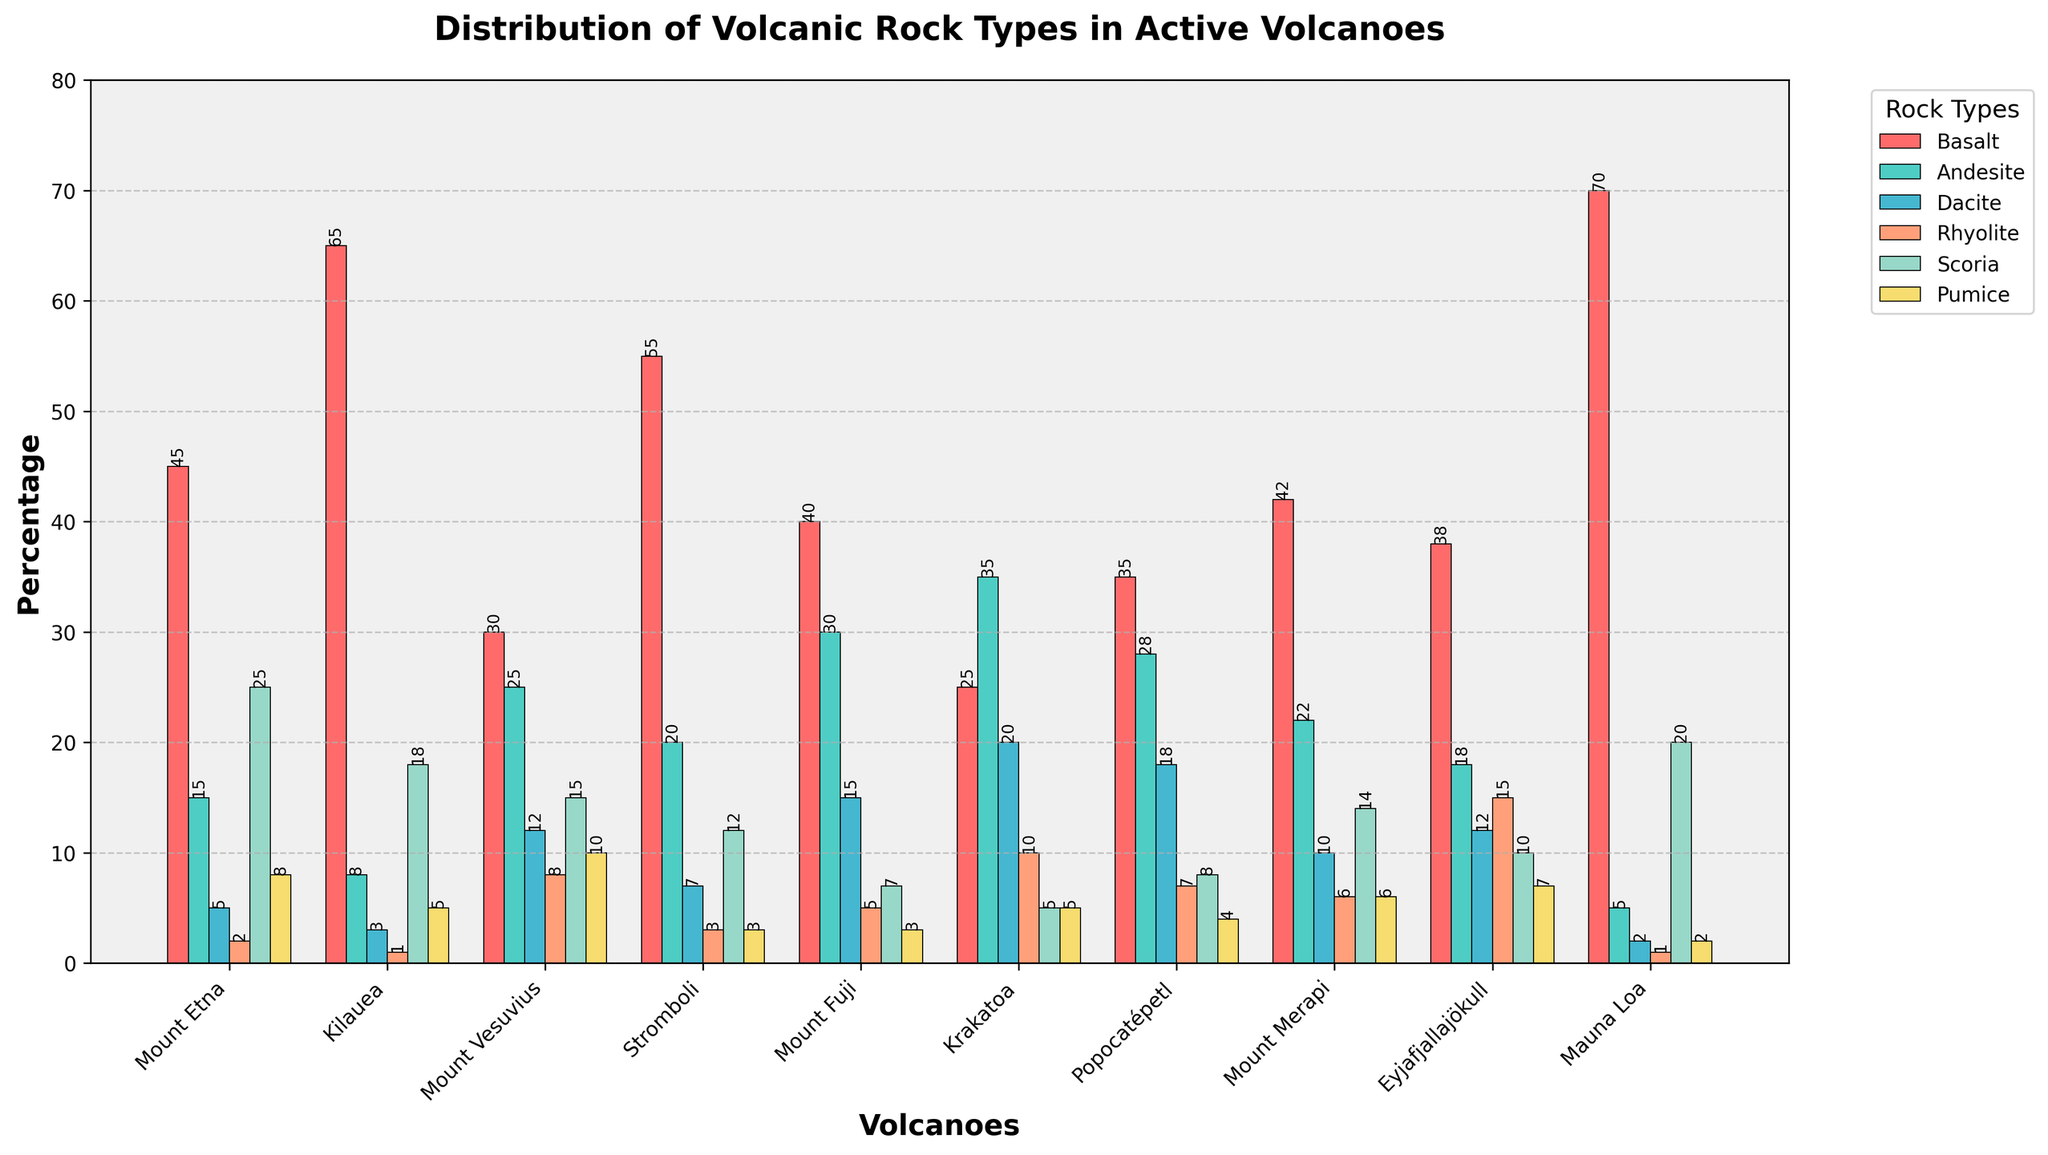Which volcano has the highest percentage of basalt? The bar representing basalt for each volcano can be compared visually. The tallest bar is for Mauna Loa.
Answer: Mauna Loa How many total rock types does Mount Fuji have a greater percentage of compared to Kilauea? List the percentages for each rock type for Mount Fuji and Kilauea, then compare each pair. Mount Fuji has higher percentages of Andesite, Dacite, and Rhyolite.
Answer: 3 What is the combined percentage of Rhyolite for Mount Vesuvius and Eyjafjallajökull? The figure provides that Mount Vesuvius has 8% and Eyjafjallajökull has 15% for Rhyolite. Summing these gives 8 + 15 = 23.
Answer: 23 Which volcano has the smallest total percentage of rock types displayed? Sum the percentages for each volcano. The volcano with the smallest total is Kilauea (100%).
Answer: Kilauea Is the percentage of Scoria at Krakatoa greater than the percentage of Pumice at Kilauea? The figure shows that Krakatoa has 5% Scoria and Kilauea has 5% Pumice. 5 is not greater than 5.
Answer: No Which volcano has the highest diversity in rock types based on the different rock types' visual heights being more evenly distributed? By observing the bar heights for each rock type of each volcano, Mount Vesuvius shows more variance yet diverse contributions across all rock types.
Answer: Mount Vesuvius What is the difference in the percentage of Basalt between Mount Etna and Mauna Loa? The figure shows Mount Etna with 45% Basalt and Mauna Loa with 70% Basalt. The difference is 70 - 45 = 25.
Answer: 25 Among the rock types for Stromboli, which has the largest percentage? The tallest bar for Stromboli corresponds to Basalt.
Answer: Basalt Is the percentage of Andesite in Mount Merapi higher than the percentage of Dacite in Mount Fuji? The chart shows Mount Merapi has 22% Andesite and Mount Fuji has 15% Dacite. 22 is greater than 15.
Answer: Yes 